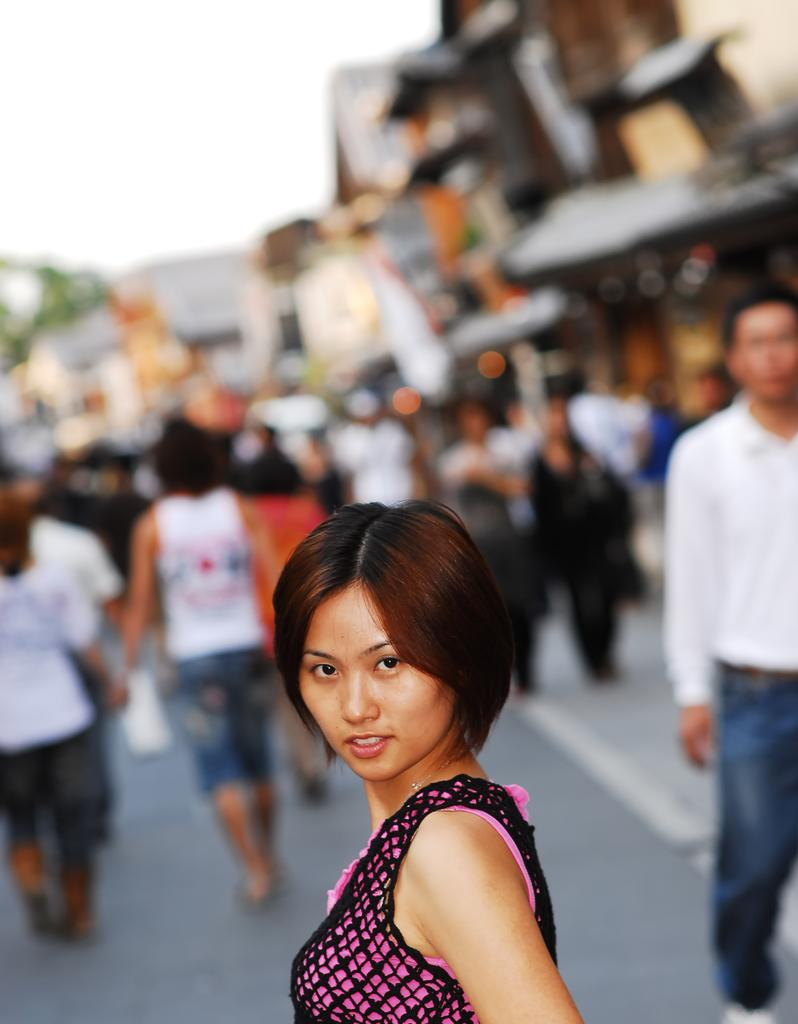Who is present in the image? There is a woman in the image. What is the woman's facial expression? The woman is smiling. Can you describe the background of the image? The background of the image is blurry. Are there any other people visible in the image? Yes, there are people visible in the background. What part of the natural environment can be seen in the image? The sky is visible in the background. What type of texture can be seen on the duck's feathers in the image? There is no duck present in the image, so it is not possible to determine the texture of its feathers. 